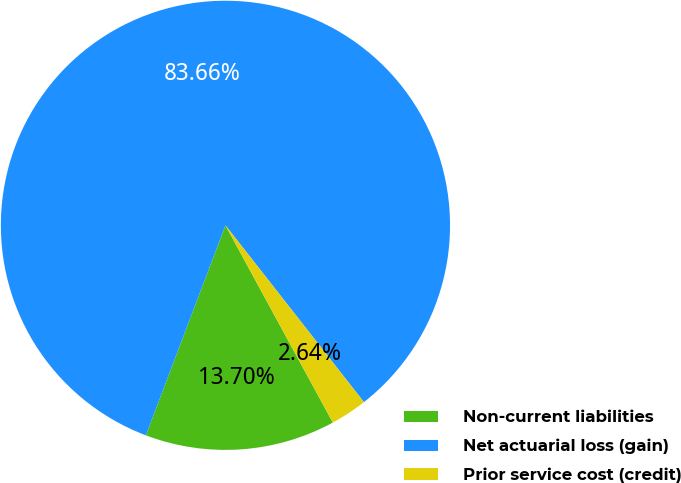<chart> <loc_0><loc_0><loc_500><loc_500><pie_chart><fcel>Non-current liabilities<fcel>Net actuarial loss (gain)<fcel>Prior service cost (credit)<nl><fcel>13.7%<fcel>83.66%<fcel>2.64%<nl></chart> 